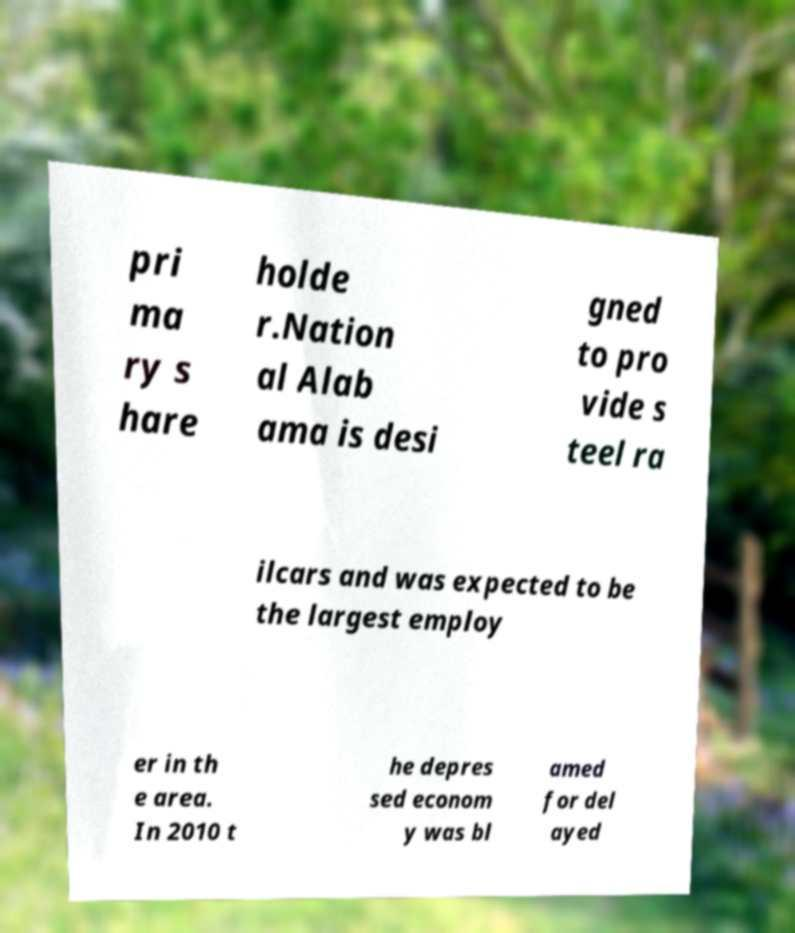Can you accurately transcribe the text from the provided image for me? pri ma ry s hare holde r.Nation al Alab ama is desi gned to pro vide s teel ra ilcars and was expected to be the largest employ er in th e area. In 2010 t he depres sed econom y was bl amed for del ayed 